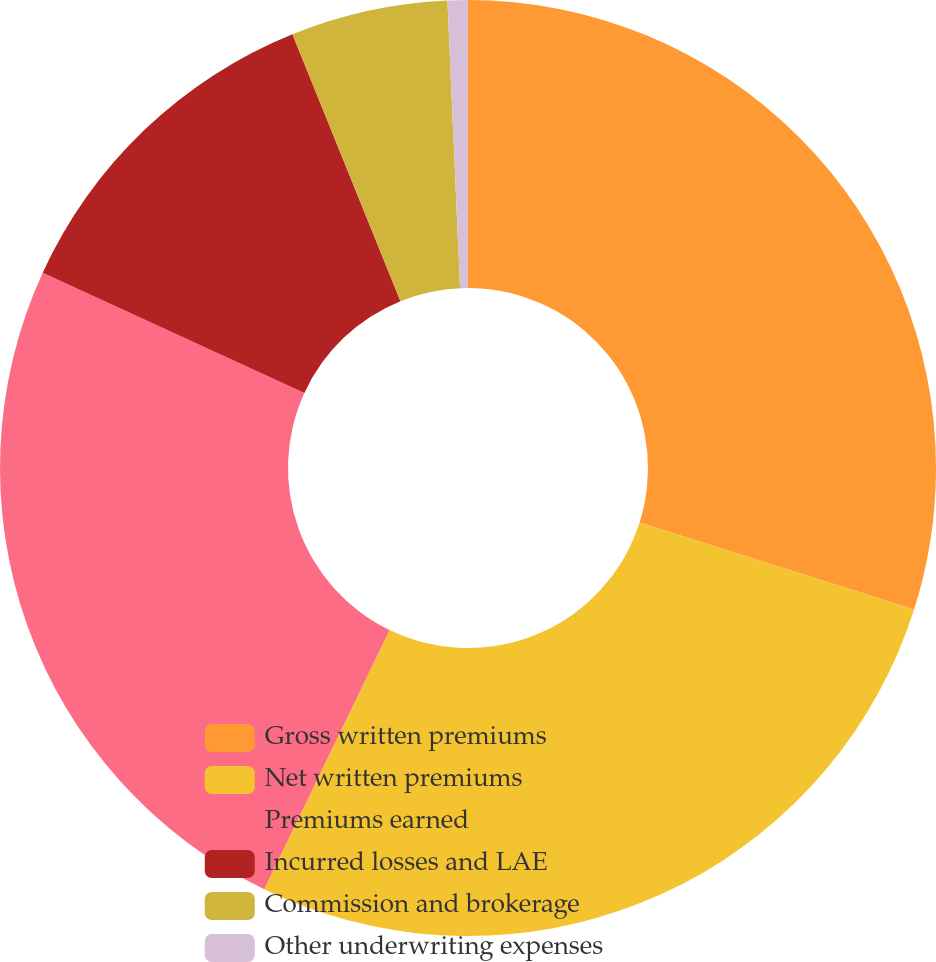Convert chart. <chart><loc_0><loc_0><loc_500><loc_500><pie_chart><fcel>Gross written premiums<fcel>Net written premiums<fcel>Premiums earned<fcel>Incurred losses and LAE<fcel>Commission and brokerage<fcel>Other underwriting expenses<nl><fcel>29.89%<fcel>27.28%<fcel>24.68%<fcel>12.03%<fcel>5.42%<fcel>0.7%<nl></chart> 